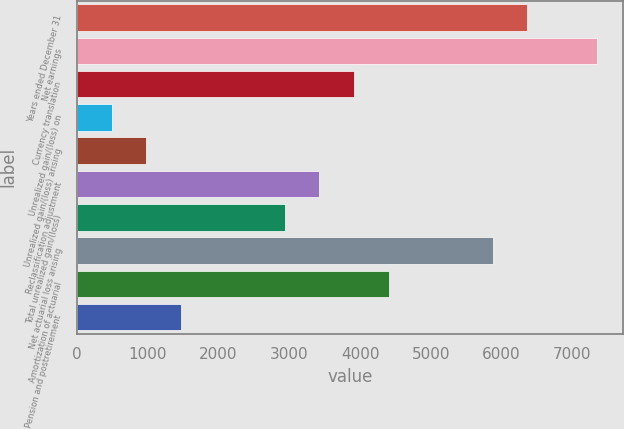Convert chart to OTSL. <chart><loc_0><loc_0><loc_500><loc_500><bar_chart><fcel>Years ended December 31<fcel>Net earnings<fcel>Currency translation<fcel>Unrealized gain/(loss) on<fcel>Unrealized gain/(loss) arising<fcel>Reclassification adjustment<fcel>Total unrealized gain/(loss)<fcel>Net actuarial loss arising<fcel>Amortization of actuarial<fcel>Pension and postretirement<nl><fcel>6363.2<fcel>7342<fcel>3916.2<fcel>490.4<fcel>979.8<fcel>3426.8<fcel>2937.4<fcel>5873.8<fcel>4405.6<fcel>1469.2<nl></chart> 